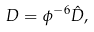Convert formula to latex. <formula><loc_0><loc_0><loc_500><loc_500>D = \phi ^ { - 6 } \hat { D } ,</formula> 